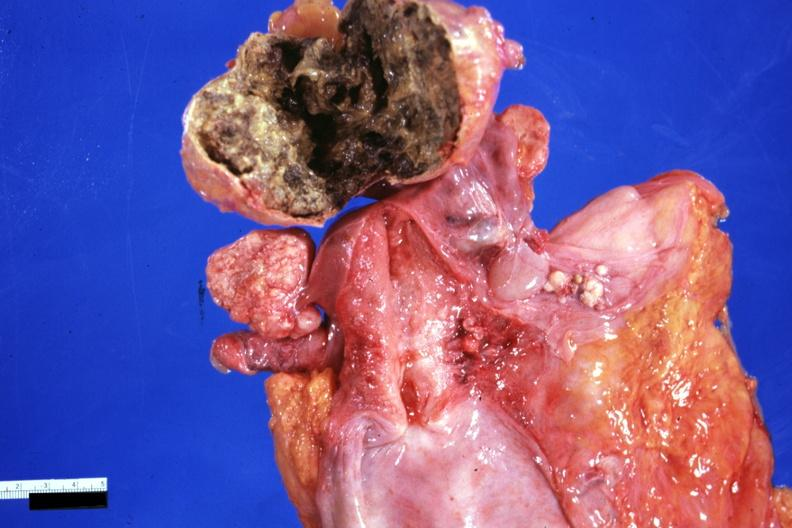where does this part belong to?
Answer the question using a single word or phrase. Female reproductive system 